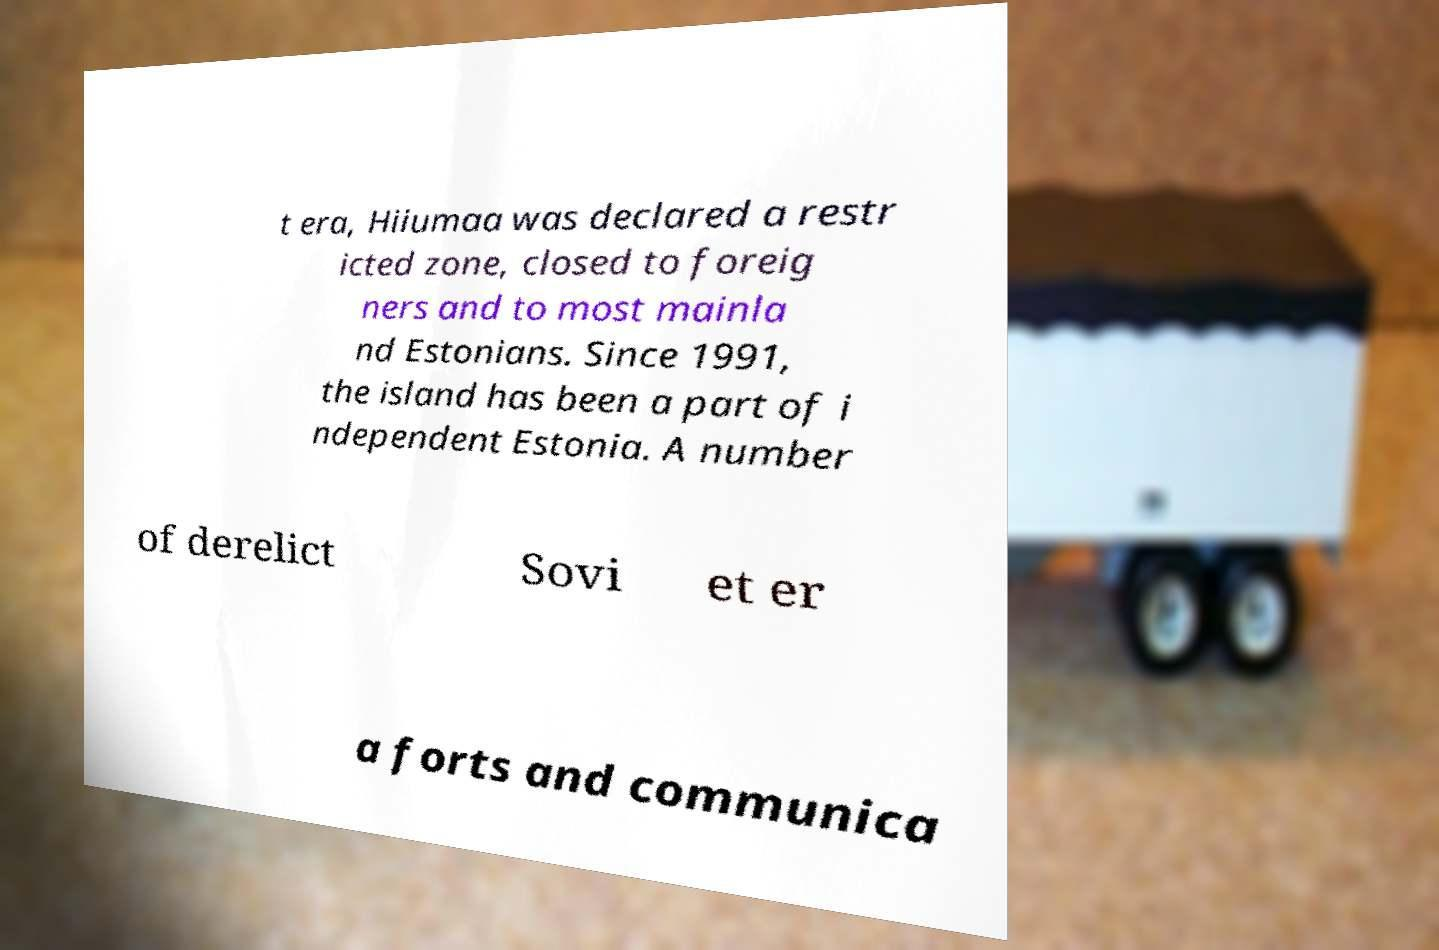For documentation purposes, I need the text within this image transcribed. Could you provide that? t era, Hiiumaa was declared a restr icted zone, closed to foreig ners and to most mainla nd Estonians. Since 1991, the island has been a part of i ndependent Estonia. A number of derelict Sovi et er a forts and communica 